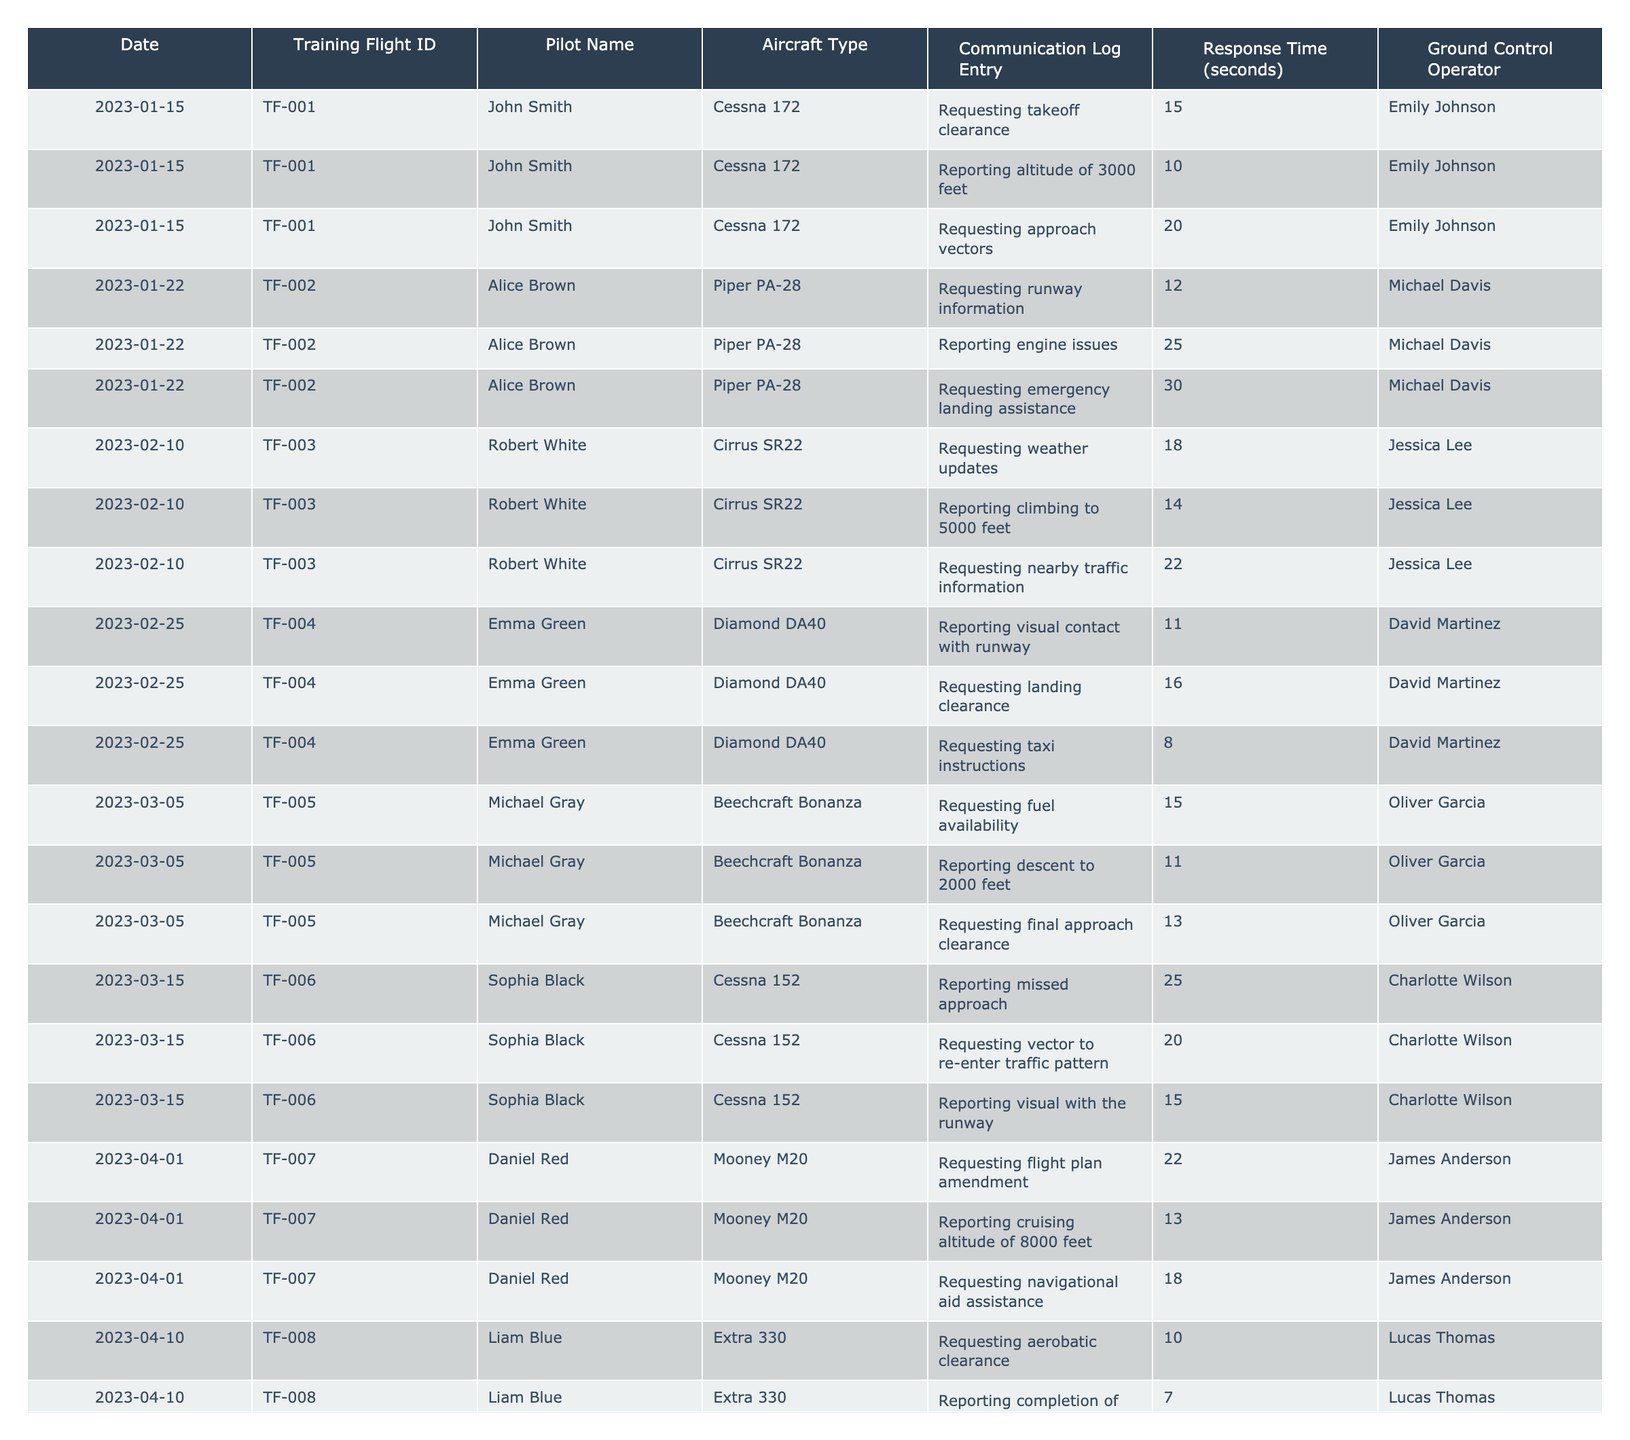What is the response time for John Smith's request for takeoff clearance? The table indicates that John Smith requested takeoff clearance on January 15, 2023, and the response time recorded for that entry is 15 seconds.
Answer: 15 seconds Which ground control operator responded to Alice Brown during her flight? According to the table, Alice Brown's training flight communications were handled by Michael Davis on January 22, 2023.
Answer: Michael Davis What is the longest response time recorded in the table? By examining the response times, the longest one is associated with Alice Brown's request for emergency landing assistance, which took 30 seconds.
Answer: 30 seconds How many communication log entries did Sophia Black have on March 15, 2023? Sophia Black has three entries on her training flight on that date, including reporting missed approach, requesting vector, and reporting visual with the runway.
Answer: 3 entries What was the average response time for all the requests made by Robert White? Robert White made three requests with response times of 18, 14, and 22 seconds. Summing these gives 54 seconds. To find the average, divide by the number of requests: 54 / 3 = 18 seconds.
Answer: 18 seconds Did any pilots request landing clearance during their training flights? Yes, the table shows that Emma Green requested landing clearance on February 25, 2023.
Answer: Yes On which date did Liam Blue make requests for aerobatic clearance? The table notes that Liam Blue's requests were on April 10, 2023.
Answer: April 10, 2023 What is the total response time for all communications made by Daniel Red? Daniel Red had three communications: response times of 22, 13, and 18 seconds. Adding these gives 53 seconds.
Answer: 53 seconds Which aircraft type had the shortest average response time in the logs? By calculating the average response times for each aircraft type, we find that the Extra 330 (Liam Blue) had an average response time of 9 seconds, which is the shortest.
Answer: Extra 330 Who had the second-highest response time when reporting a request? Alice Brown had the second-highest response time at 25 seconds when she reported engine issues on January 22, 2023.
Answer: Alice Brown 